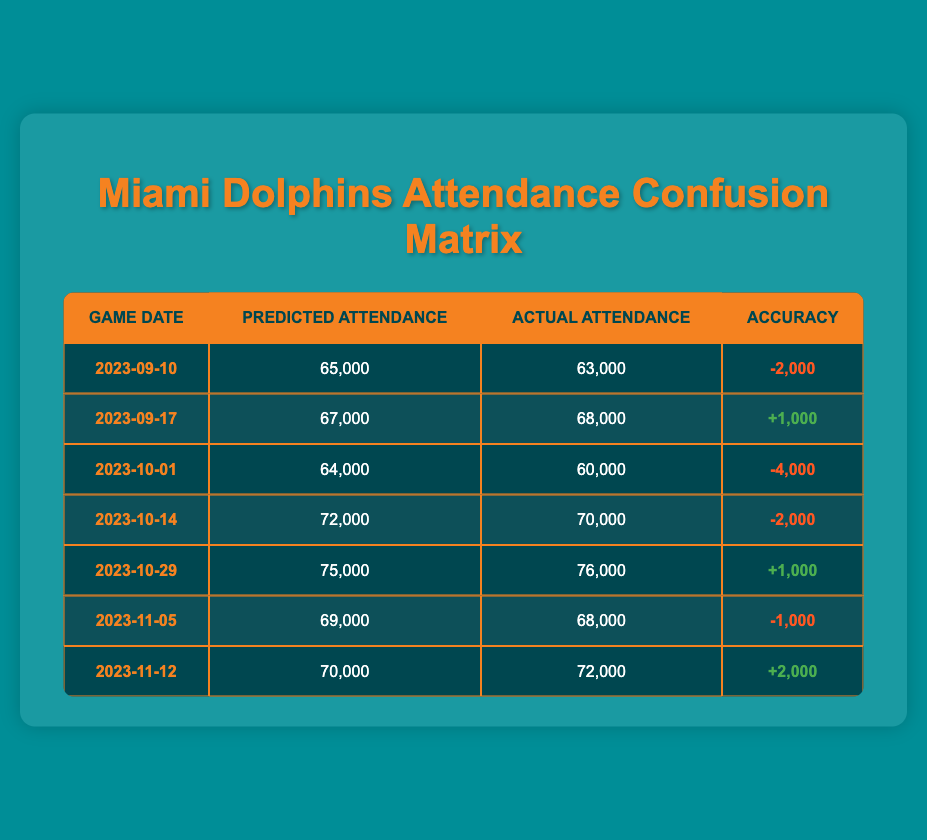What was the predicted attendance for the game on 2023-10-01? According to the table, the predicted attendance for the game dated 2023-10-01 is listed under the "Predicted Attendance" column, which shows 64,000.
Answer: 64,000 How many games had an accurate attendance prediction? The table shows two games with a positive difference between predicted and actual attendance (2023-09-17: +1,000 and 2023-10-29: +1,000). Additionally, the game on 2023-11-12 also has a positive difference of +2,000. Therefore, there are three games with accurate attendance predictions.
Answer: 3 What was the average actual attendance across all games? To find the average actual attendance, sum the actual attendances: 63,000 + 68,000 + 60,000 + 70,000 + 76,000 + 68,000 + 72,000 = 477,000. There are 7 data points, so the average is 477,000 divided by 7, which equals 68,142.857. Rounding this gives approximately 68,143.
Answer: 68,143 Did the attendance prediction for 2023-09-10 underpredict the actual attendance? The actual attendance for the game on 2023-09-10 was 63,000, while the predicted attendance was 65,000. Since the predicted attendance is greater than the actual attendance, the prediction did underpredict in this case.
Answer: Yes Which game had the highest predicted attendance, and was it accurate? The highest predicted attendance was for the game on 2023-10-29, at 75,000. The actual attendance was 76,000, resulting in an accuracy of +1,000; this indicates the prediction was inaccurate.
Answer: 2023-10-29; No How many games had an underprediction of attendance? From the table, underpredictions occur if the predicted attendance is less than the actual, which applies to games on 2023-09-10, 2023-10-01, 2023-10-14, 2023-11-05, and 2023-11-12. Thus, there are five games with underpredictions.
Answer: 5 What was the total difference between predicted and actual attendance for all games? First, calculate individual differences: (65,000 - 63,000) + (67,000 - 68,000) + (64,000 - 60,000) + (72,000 - 70,000) + (75,000 - 76,000) + (69,000 - 68,000) + (70,000 - 72,000) = 2,000 - 1,000 - 4,000 - 2,000 - 1,000 + 2,000 = -4,000, which means the total difference is -4,000.
Answer: -4,000 